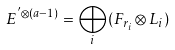Convert formula to latex. <formula><loc_0><loc_0><loc_500><loc_500>E ^ { ^ { \prime } \otimes ( a - 1 ) } = \bigoplus _ { i } ( F _ { r _ { i } } \otimes L _ { i } )</formula> 